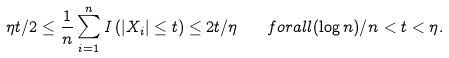<formula> <loc_0><loc_0><loc_500><loc_500>\eta t / 2 \leq \frac { 1 } { n } \sum _ { i = 1 } ^ { n } I \left ( | X _ { i } | \leq t \right ) \leq 2 t / \eta \quad f o r a l l ( \log n ) / n < t < \eta .</formula> 